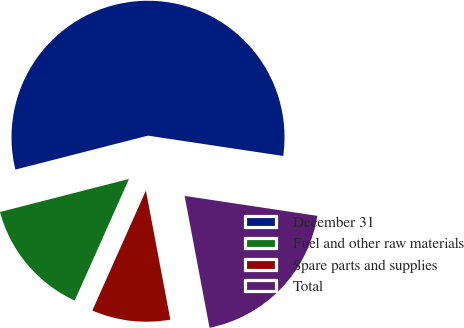Convert chart to OTSL. <chart><loc_0><loc_0><loc_500><loc_500><pie_chart><fcel>December 31<fcel>Fuel and other raw materials<fcel>Spare parts and supplies<fcel>Total<nl><fcel>56.37%<fcel>14.33%<fcel>9.66%<fcel>19.65%<nl></chart> 